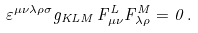Convert formula to latex. <formula><loc_0><loc_0><loc_500><loc_500>\varepsilon ^ { \mu \nu \lambda \rho \sigma } g _ { K L M } \, F _ { \mu \nu } ^ { L } F _ { \lambda \rho } ^ { M } = 0 \, .</formula> 